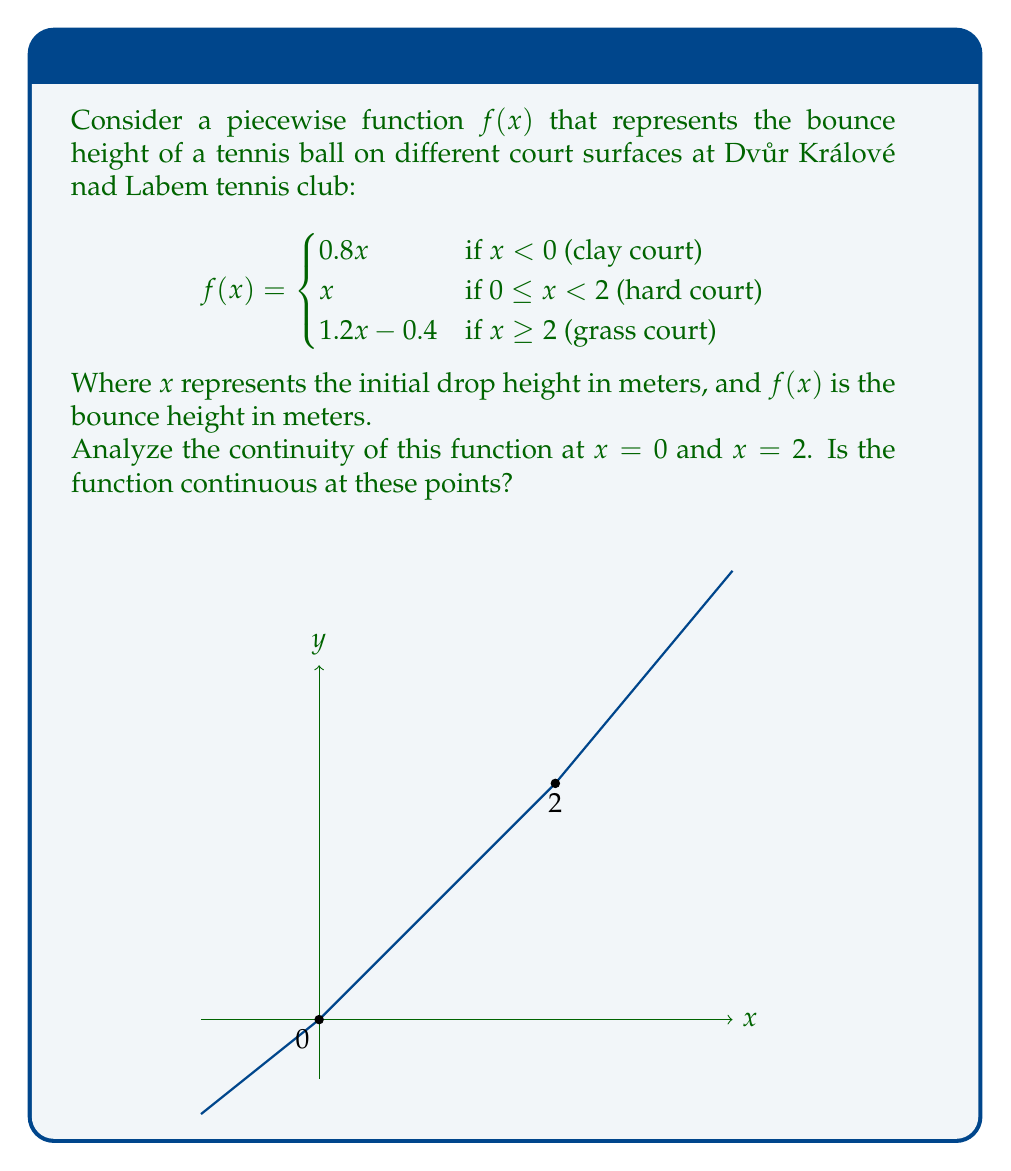Help me with this question. To analyze the continuity of the piecewise function at $x = 0$ and $x = 2$, we need to check three conditions for each point:

1. The function is defined at the point.
2. The limit of the function as we approach the point from both sides exists.
3. The limit equals the function value at that point.

For $x = 0$:

1. $f(0)$ is defined: $f(0) = 0$ (using the second piece of the function)
2. Left-hand limit:
   $\lim_{x \to 0^-} f(x) = \lim_{x \to 0^-} 0.8x = 0$
   Right-hand limit:
   $\lim_{x \to 0^+} f(x) = \lim_{x \to 0^+} x = 0$
3. $\lim_{x \to 0^-} f(x) = \lim_{x \to 0^+} f(x) = f(0) = 0$

Therefore, $f(x)$ is continuous at $x = 0$.

For $x = 2$:

1. $f(2)$ is defined: $f(2) = 2$ (using the second piece of the function)
2. Left-hand limit:
   $\lim_{x \to 2^-} f(x) = \lim_{x \to 2^-} x = 2$
   Right-hand limit:
   $\lim_{x \to 2^+} f(x) = \lim_{x \to 2^+} (1.2x - 0.4) = 1.2(2) - 0.4 = 2$
3. $\lim_{x \to 2^-} f(x) = \lim_{x \to 2^+} f(x) = f(2) = 2$

Therefore, $f(x)$ is also continuous at $x = 2$.
Answer: The function is continuous at both $x = 0$ and $x = 2$. 